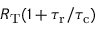Convert formula to latex. <formula><loc_0><loc_0><loc_500><loc_500>R _ { T } ( 1 + { \tau _ { r } } / { \tau _ { c } } )</formula> 